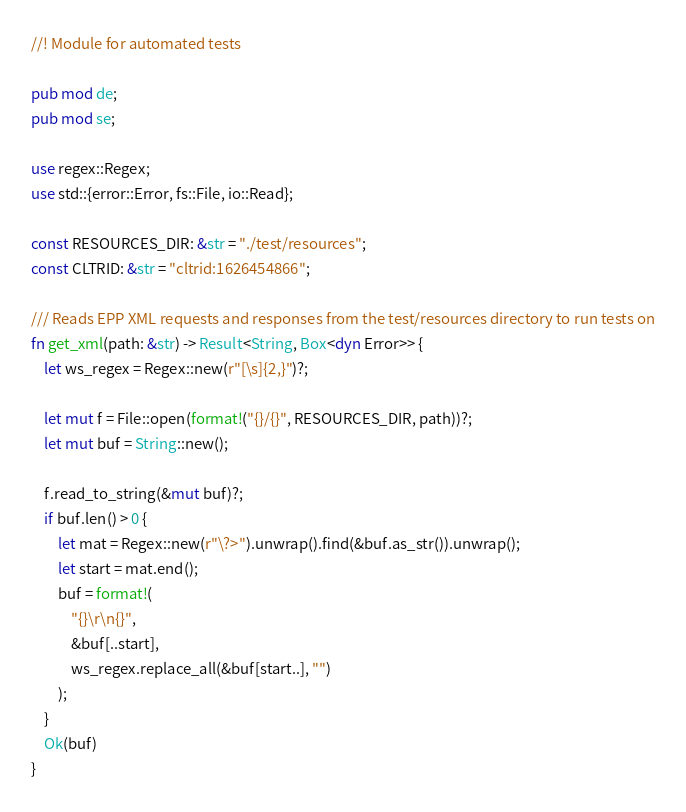Convert code to text. <code><loc_0><loc_0><loc_500><loc_500><_Rust_>//! Module for automated tests

pub mod de;
pub mod se;

use regex::Regex;
use std::{error::Error, fs::File, io::Read};

const RESOURCES_DIR: &str = "./test/resources";
const CLTRID: &str = "cltrid:1626454866";

/// Reads EPP XML requests and responses from the test/resources directory to run tests on
fn get_xml(path: &str) -> Result<String, Box<dyn Error>> {
    let ws_regex = Regex::new(r"[\s]{2,}")?;

    let mut f = File::open(format!("{}/{}", RESOURCES_DIR, path))?;
    let mut buf = String::new();

    f.read_to_string(&mut buf)?;
    if buf.len() > 0 {
        let mat = Regex::new(r"\?>").unwrap().find(&buf.as_str()).unwrap();
        let start = mat.end();
        buf = format!(
            "{}\r\n{}",
            &buf[..start],
            ws_regex.replace_all(&buf[start..], "")
        );
    }
    Ok(buf)
}
</code> 